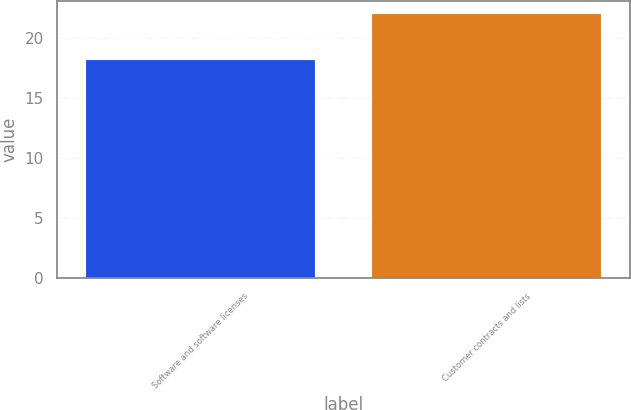<chart> <loc_0><loc_0><loc_500><loc_500><bar_chart><fcel>Software and software licenses<fcel>Customer contracts and lists<nl><fcel>18.2<fcel>22<nl></chart> 